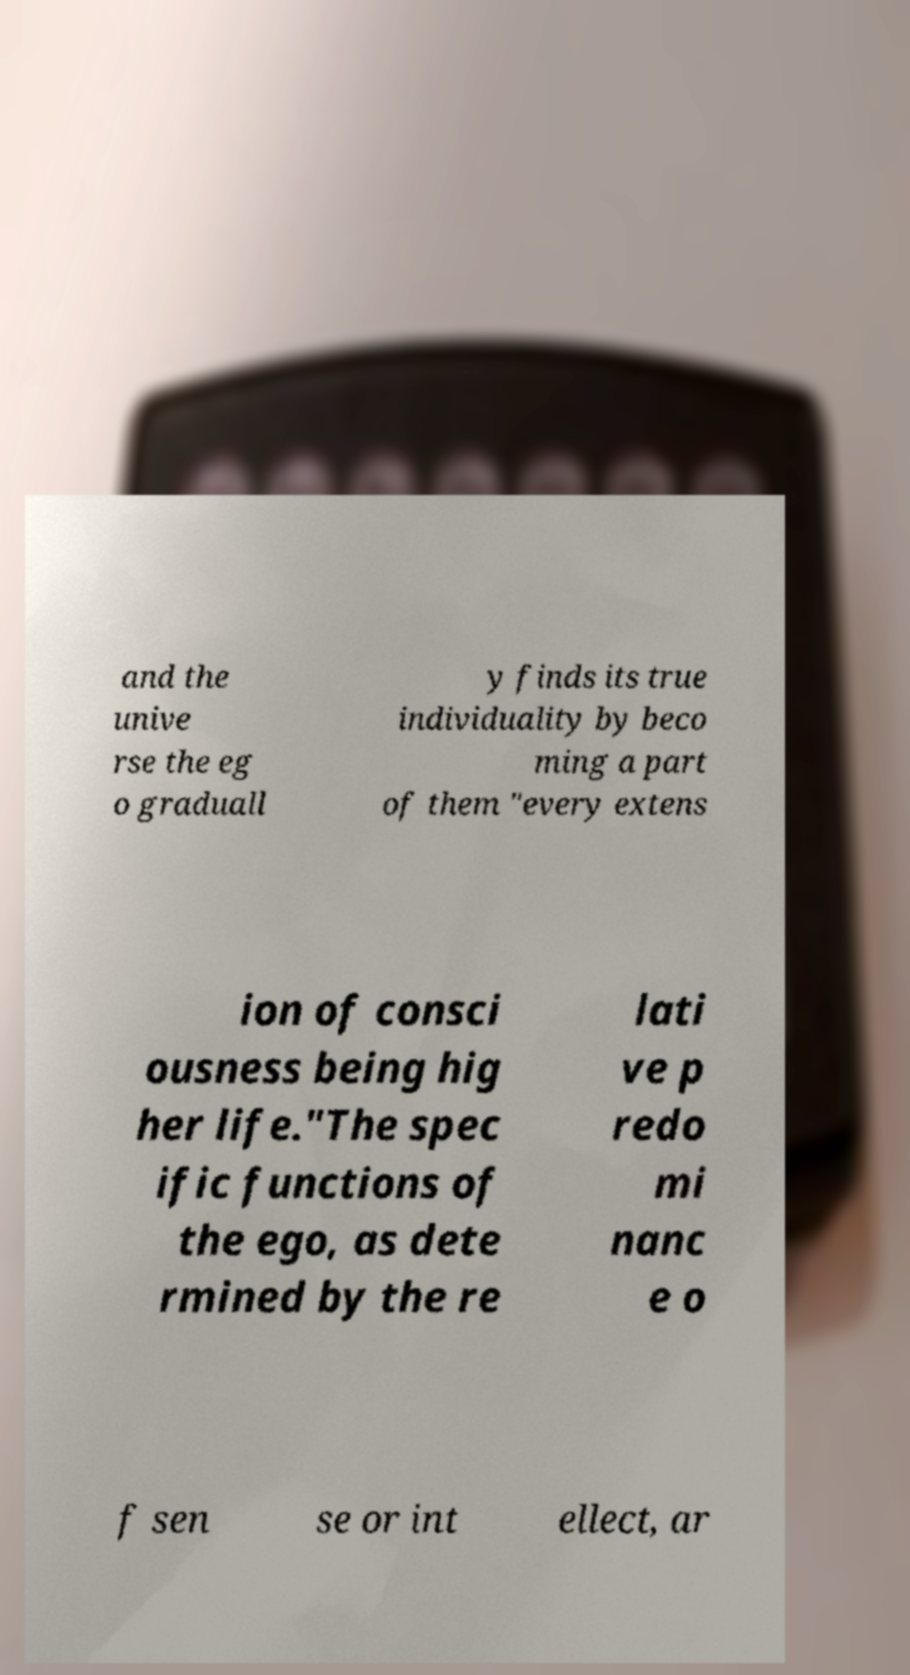For documentation purposes, I need the text within this image transcribed. Could you provide that? and the unive rse the eg o graduall y finds its true individuality by beco ming a part of them "every extens ion of consci ousness being hig her life."The spec ific functions of the ego, as dete rmined by the re lati ve p redo mi nanc e o f sen se or int ellect, ar 